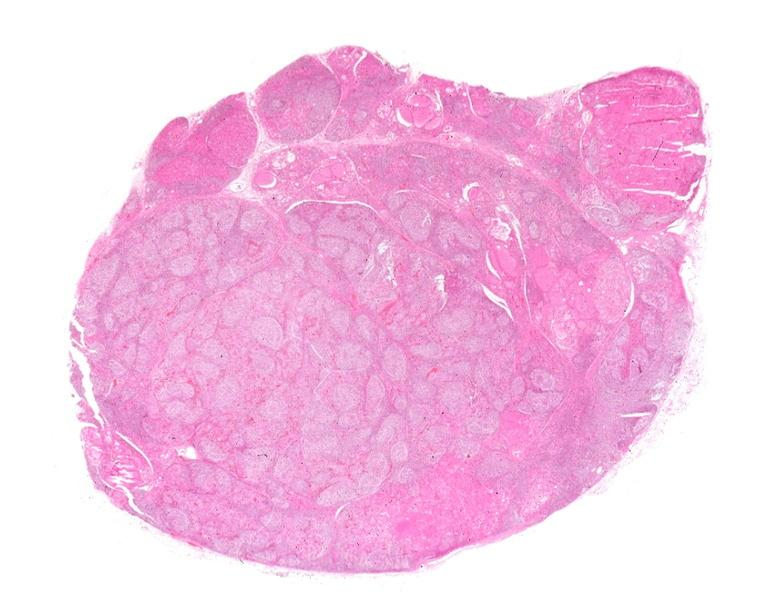does this image show hashimoto 's thyroiditis?
Answer the question using a single word or phrase. Yes 